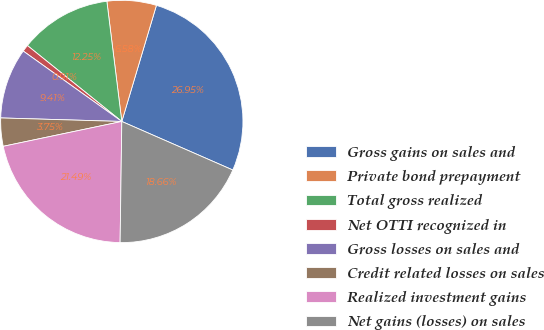Convert chart. <chart><loc_0><loc_0><loc_500><loc_500><pie_chart><fcel>Gross gains on sales and<fcel>Private bond prepayment<fcel>Total gross realized<fcel>Net OTTI recognized in<fcel>Gross losses on sales and<fcel>Credit related losses on sales<fcel>Realized investment gains<fcel>Net gains (losses) on sales<nl><fcel>26.95%<fcel>6.58%<fcel>12.25%<fcel>0.91%<fcel>9.41%<fcel>3.75%<fcel>21.49%<fcel>18.66%<nl></chart> 